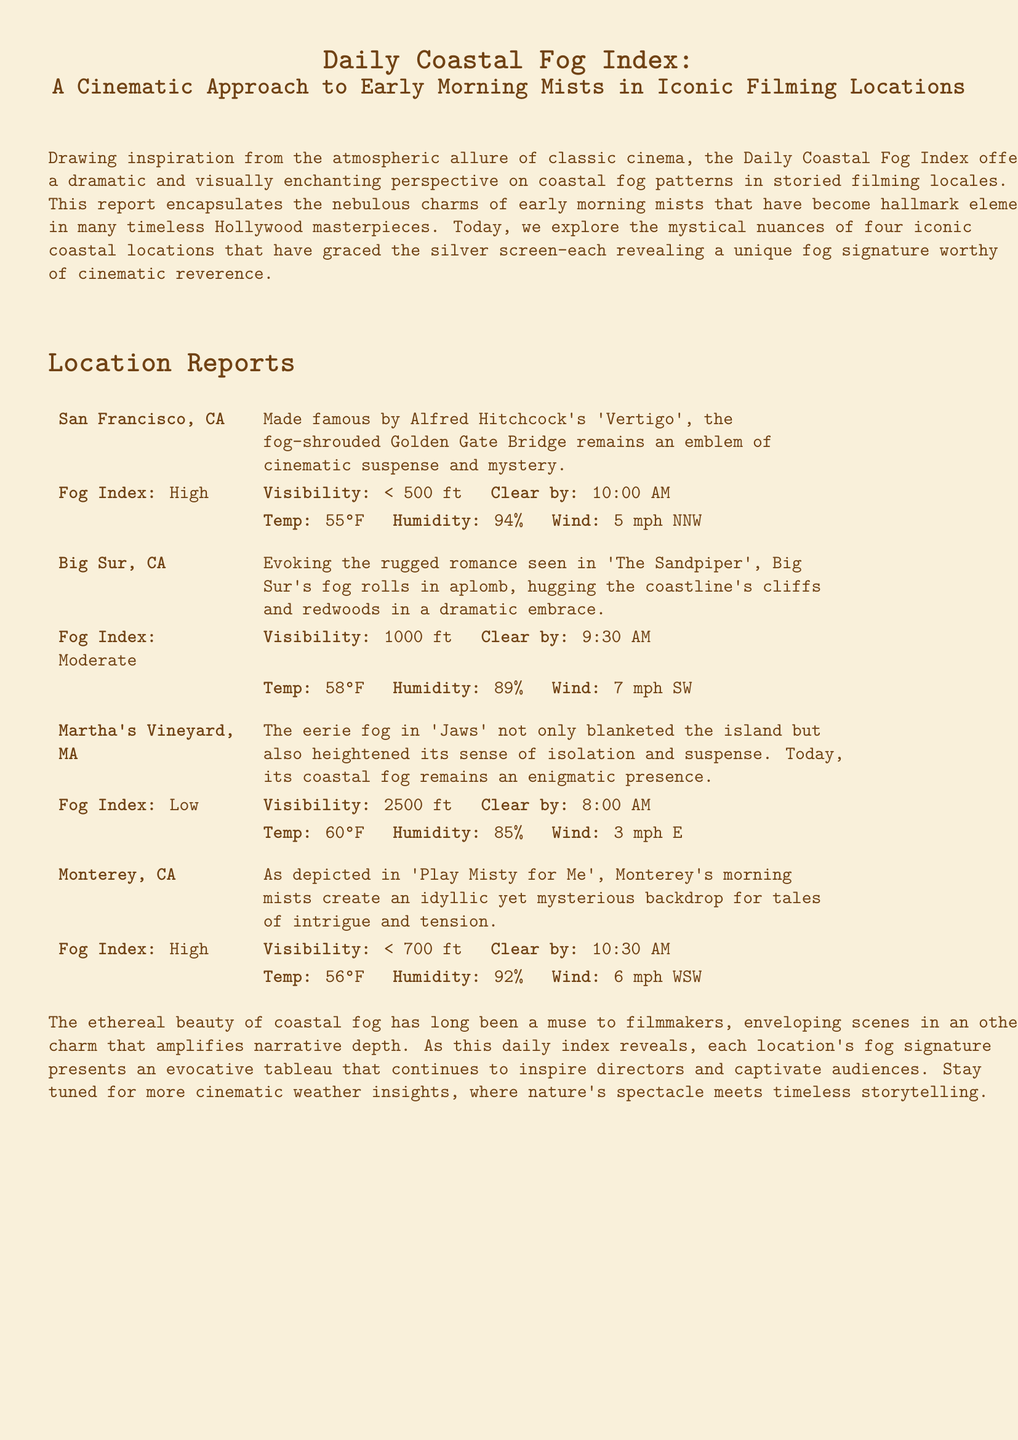what is the fog index for San Francisco? The fog index for San Francisco is specified as "High" in the document.
Answer: High what is the visibility in Big Sur? The visibility in Big Sur is noted to be "1000 ft" according to the report.
Answer: 1000 ft what film made San Francisco's fog famous? The film that made San Francisco's fog famous is Alfred Hitchcock's "Vertigo."
Answer: Vertigo which location has the lowest fog index? The location with the lowest fog index is Martha's Vineyard.
Answer: Martha's Vineyard what time will the fog clear in Monterey? The fog in Monterey will clear by "10:30 AM."
Answer: 10:30 AM how does the fog affect the cinematic ambiance according to the report? The document explains that fog envelops scenes in an "otherworldly charm" impacting the narrative depth.
Answer: otherworldly charm what is the humidity level in San Francisco? The humidity level in San Francisco is listed as "94%."
Answer: 94% which location experiences the earliest clearing of fog? The location that experiences the earliest clearing of fog is Martha's Vineyard at "8:00 AM."
Answer: 8:00 AM 